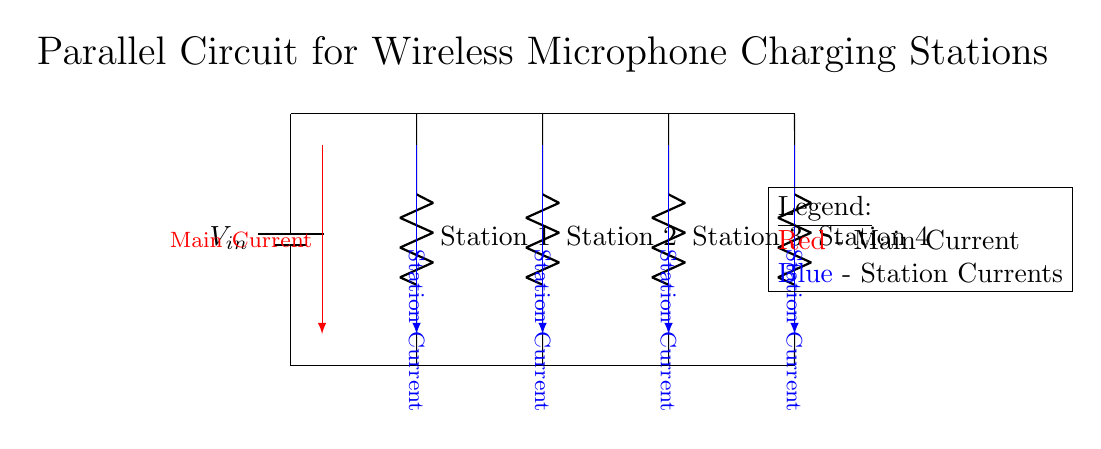What is the main component supplying power in this circuit? The main component supplying power is the battery, indicated as \(V_{in}\). It converts chemical energy into electrical energy, ensuring that the circuit operates effectively by supplying the power needed for the multiple charging stations.
Answer: battery How many charging stations are represented in the circuit? The circuit shows four charging stations, as depicted by the four resistors labeled Station 1 through Station 4. Each of these stations has an independent connection to the main voltage line, indicating they can operate simultaneously.
Answer: four What type of circuit is this? This circuit is a parallel circuit, as indicated by the multiple connections of charge stations to a single voltage source. In a parallel circuit, each component is connected across the same voltage, allowing for individual operation and the sharing of the main current.
Answer: parallel What is the color used to represent the main current in the circuit? The main current is represented in red, which clearly distinguishes it from the currents for each charging station. The color coding helps to visually differentiate the main current from the station currents, enhancing clarity in the diagram.
Answer: red What happens to the station currents if one charging station fails? If one charging station fails, the others will continue to operate normally, as each station has its own independent path from the voltage source. This is a critical feature of parallel circuits, allowing for uninterrupted service even if one component encounters an issue.
Answer: remains operational What is indicated by the currents being shown in blue? The currents shown in blue represent the individual station currents flowing to each of the four charging stations. This color differentiation helps viewers quickly identify the pathways and understand the distribution of current in the parallel circuit.
Answer: station currents 